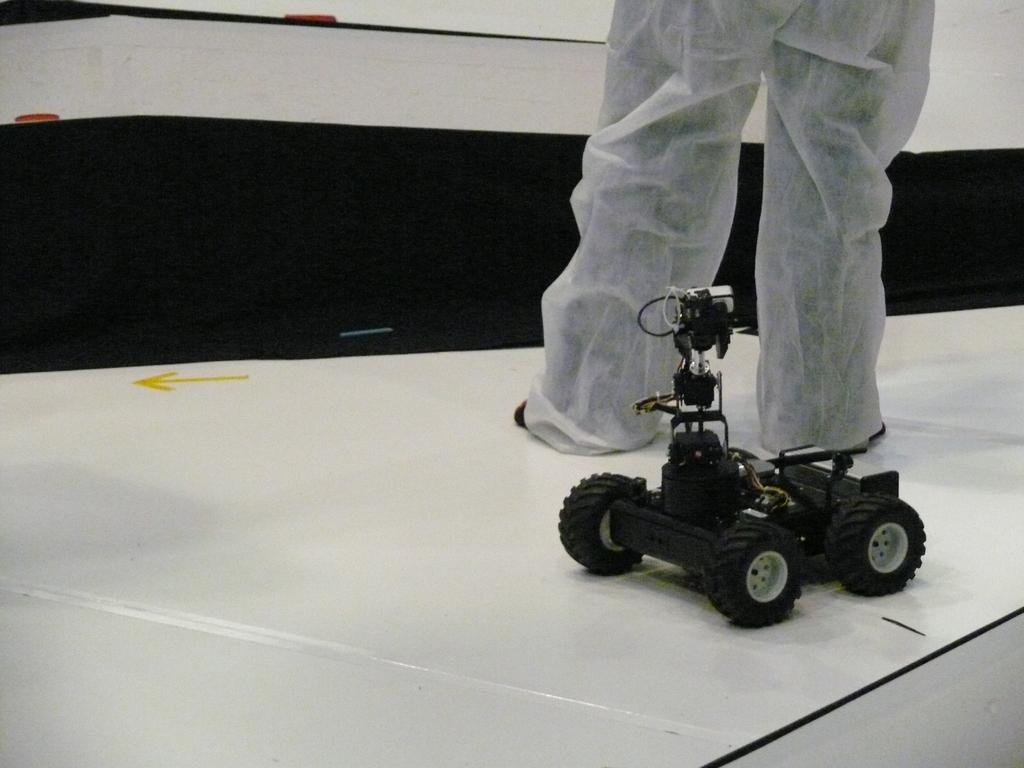Where is the person located in the image? The person is in the top right of the image. What is the person wearing that is visible in the image? The person is wearing white trousers. What type of toy can be seen in the image? There is a toy truck in the image. What color is the toy truck? The toy truck is black in color. How does the person slip on the low ray in the image? There is no ray or slipping person present in the image; it only features a person wearing white trousers and a black toy truck. 